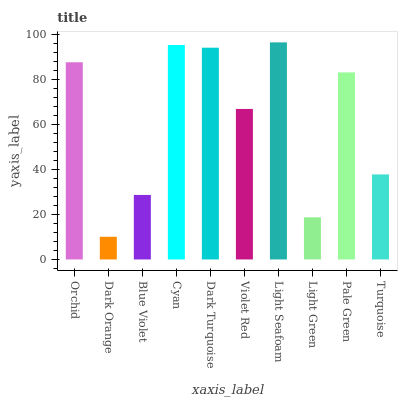Is Dark Orange the minimum?
Answer yes or no. Yes. Is Light Seafoam the maximum?
Answer yes or no. Yes. Is Blue Violet the minimum?
Answer yes or no. No. Is Blue Violet the maximum?
Answer yes or no. No. Is Blue Violet greater than Dark Orange?
Answer yes or no. Yes. Is Dark Orange less than Blue Violet?
Answer yes or no. Yes. Is Dark Orange greater than Blue Violet?
Answer yes or no. No. Is Blue Violet less than Dark Orange?
Answer yes or no. No. Is Pale Green the high median?
Answer yes or no. Yes. Is Violet Red the low median?
Answer yes or no. Yes. Is Violet Red the high median?
Answer yes or no. No. Is Pale Green the low median?
Answer yes or no. No. 